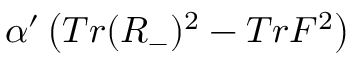<formula> <loc_0><loc_0><loc_500><loc_500>\alpha ^ { \prime } \left ( T r ( R _ { - } ) ^ { 2 } - T r F ^ { 2 } \right )</formula> 